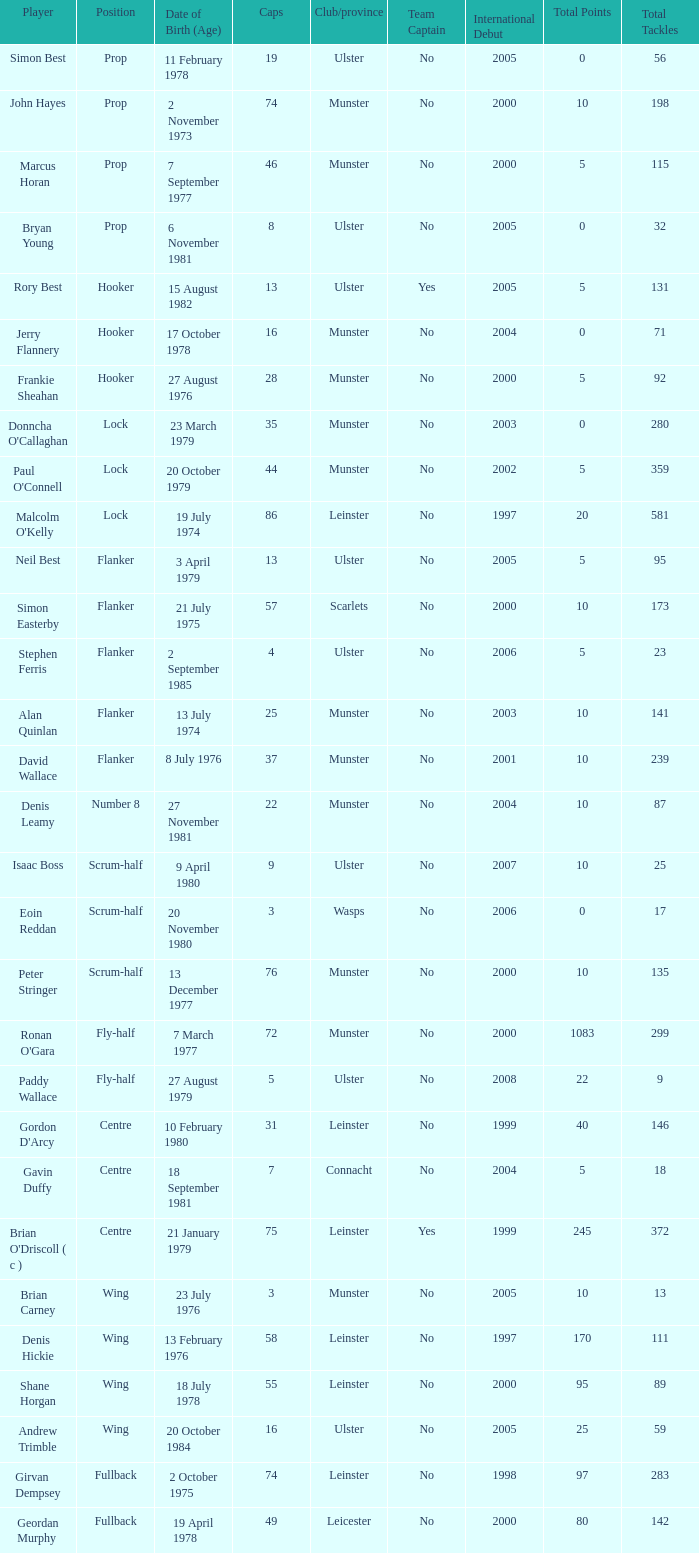Which Ulster player has fewer than 49 caps and plays the wing position? Andrew Trimble. 